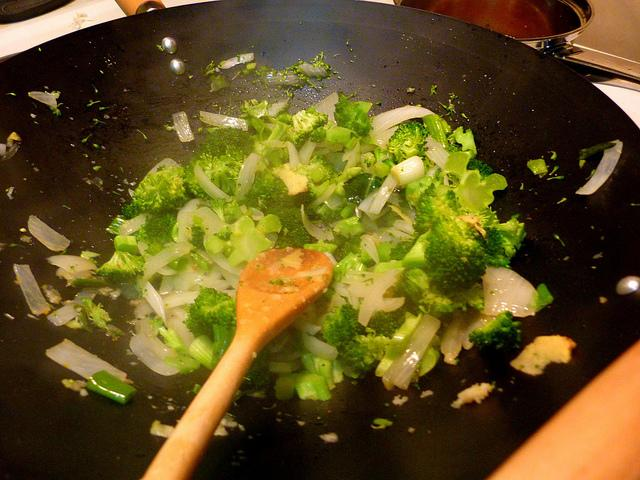What food type is in the pan? broccoli 